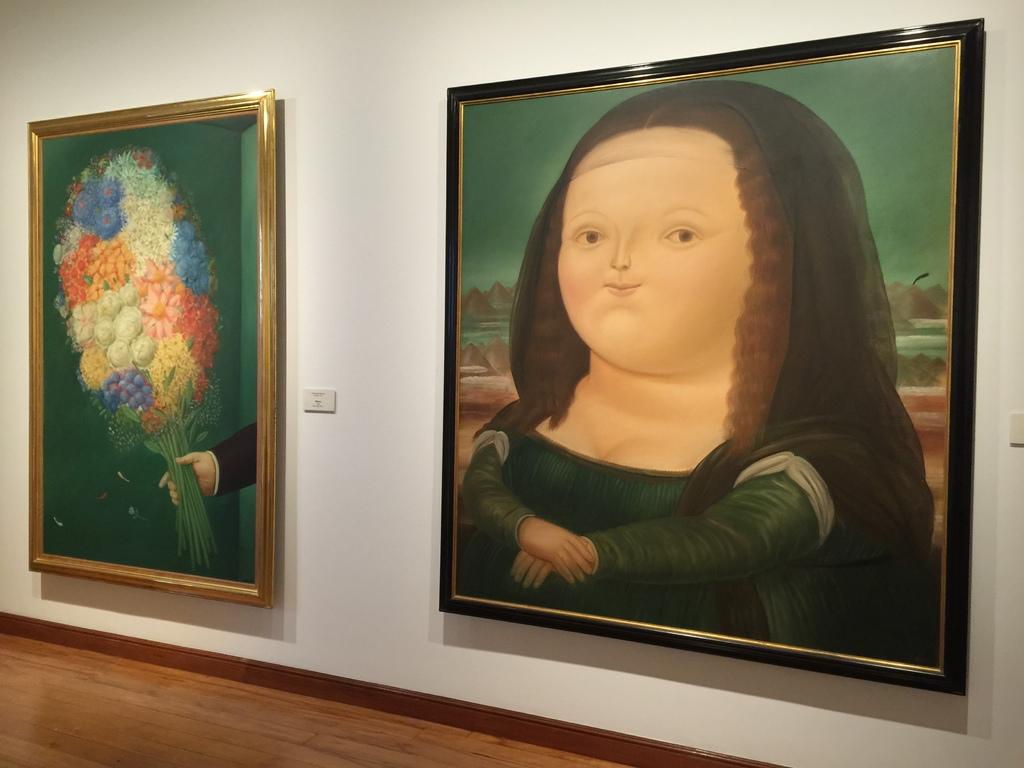What is attached to the wall in the image? There are frames attached to the wall in the image. How would you describe the wall in the image? The wall is plain. What part of the room can be seen at the bottom of the image? The floor is visible at the bottom of the image. Can you see a stocking hanging from the wall in the image? There is no stocking hanging from the wall in the image. Is there a bell ringing in the image? There is no bell present in the image. 